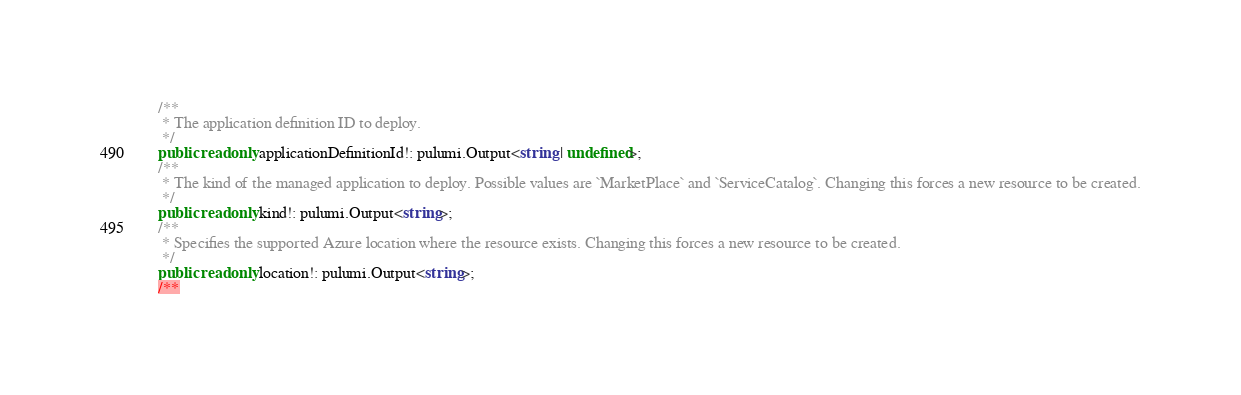Convert code to text. <code><loc_0><loc_0><loc_500><loc_500><_TypeScript_>
    /**
     * The application definition ID to deploy.
     */
    public readonly applicationDefinitionId!: pulumi.Output<string | undefined>;
    /**
     * The kind of the managed application to deploy. Possible values are `MarketPlace` and `ServiceCatalog`. Changing this forces a new resource to be created.
     */
    public readonly kind!: pulumi.Output<string>;
    /**
     * Specifies the supported Azure location where the resource exists. Changing this forces a new resource to be created.
     */
    public readonly location!: pulumi.Output<string>;
    /**</code> 